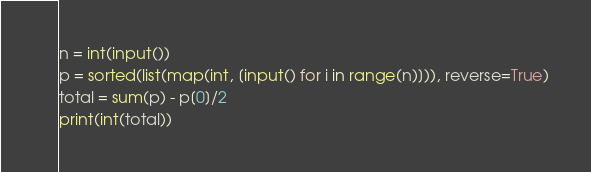Convert code to text. <code><loc_0><loc_0><loc_500><loc_500><_Python_>n = int(input())
p = sorted(list(map(int, [input() for i in range(n)])), reverse=True)
total = sum(p) - p[0]/2
print(int(total))</code> 